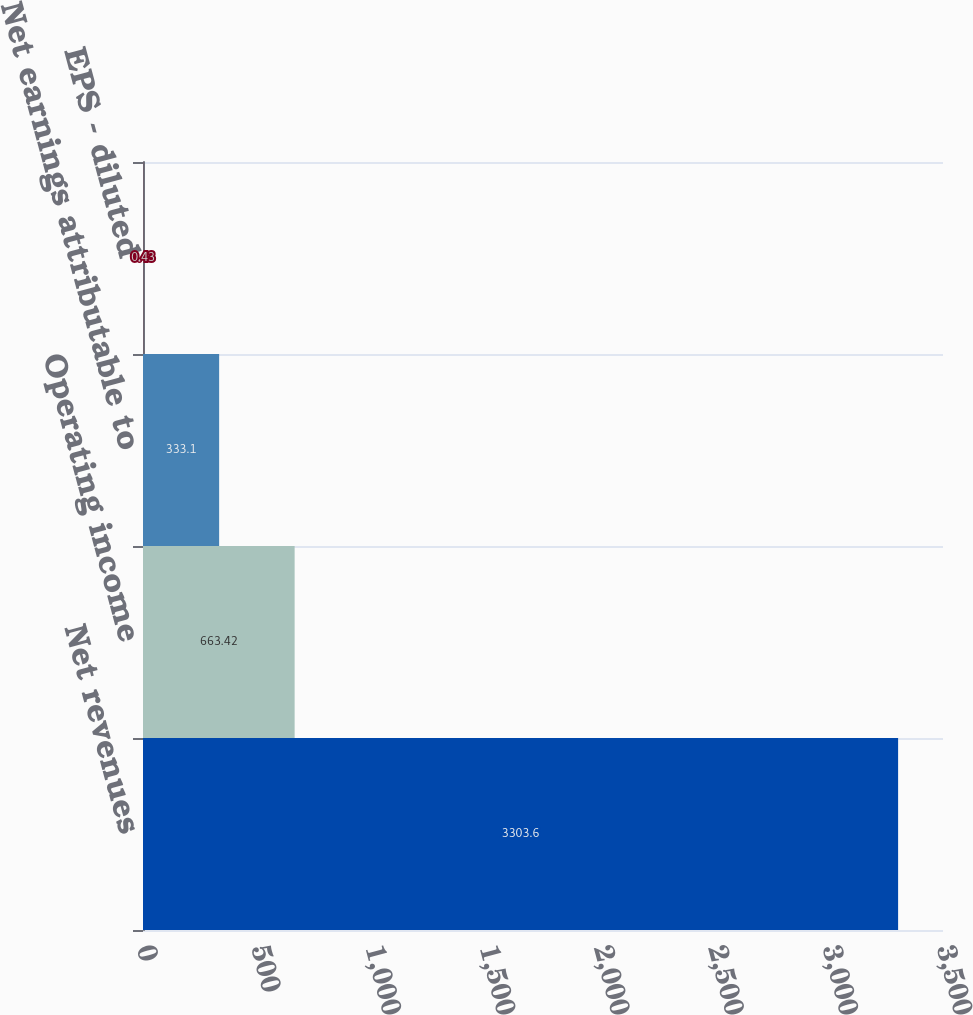<chart> <loc_0><loc_0><loc_500><loc_500><bar_chart><fcel>Net revenues<fcel>Operating income<fcel>Net earnings attributable to<fcel>EPS - diluted<nl><fcel>3303.6<fcel>663.42<fcel>333.1<fcel>0.43<nl></chart> 